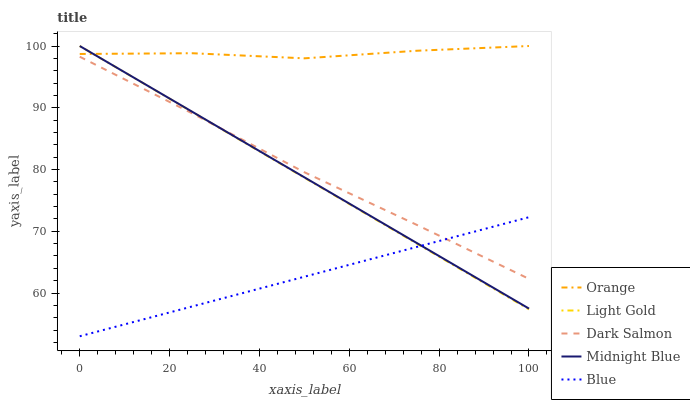Does Blue have the minimum area under the curve?
Answer yes or no. Yes. Does Orange have the maximum area under the curve?
Answer yes or no. Yes. Does Light Gold have the minimum area under the curve?
Answer yes or no. No. Does Light Gold have the maximum area under the curve?
Answer yes or no. No. Is Blue the smoothest?
Answer yes or no. Yes. Is Orange the roughest?
Answer yes or no. Yes. Is Light Gold the smoothest?
Answer yes or no. No. Is Light Gold the roughest?
Answer yes or no. No. Does Blue have the lowest value?
Answer yes or no. Yes. Does Light Gold have the lowest value?
Answer yes or no. No. Does Midnight Blue have the highest value?
Answer yes or no. Yes. Does Blue have the highest value?
Answer yes or no. No. Is Blue less than Orange?
Answer yes or no. Yes. Is Orange greater than Dark Salmon?
Answer yes or no. Yes. Does Light Gold intersect Orange?
Answer yes or no. Yes. Is Light Gold less than Orange?
Answer yes or no. No. Is Light Gold greater than Orange?
Answer yes or no. No. Does Blue intersect Orange?
Answer yes or no. No. 